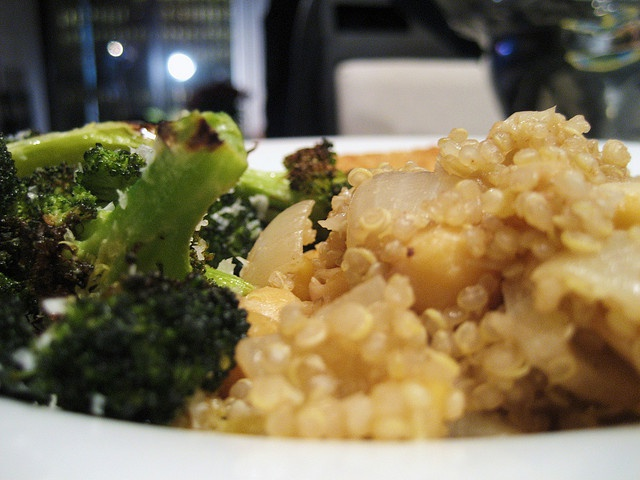Describe the objects in this image and their specific colors. I can see broccoli in black, darkgreen, and olive tones, broccoli in black, darkgreen, and olive tones, and broccoli in black, olive, and maroon tones in this image. 